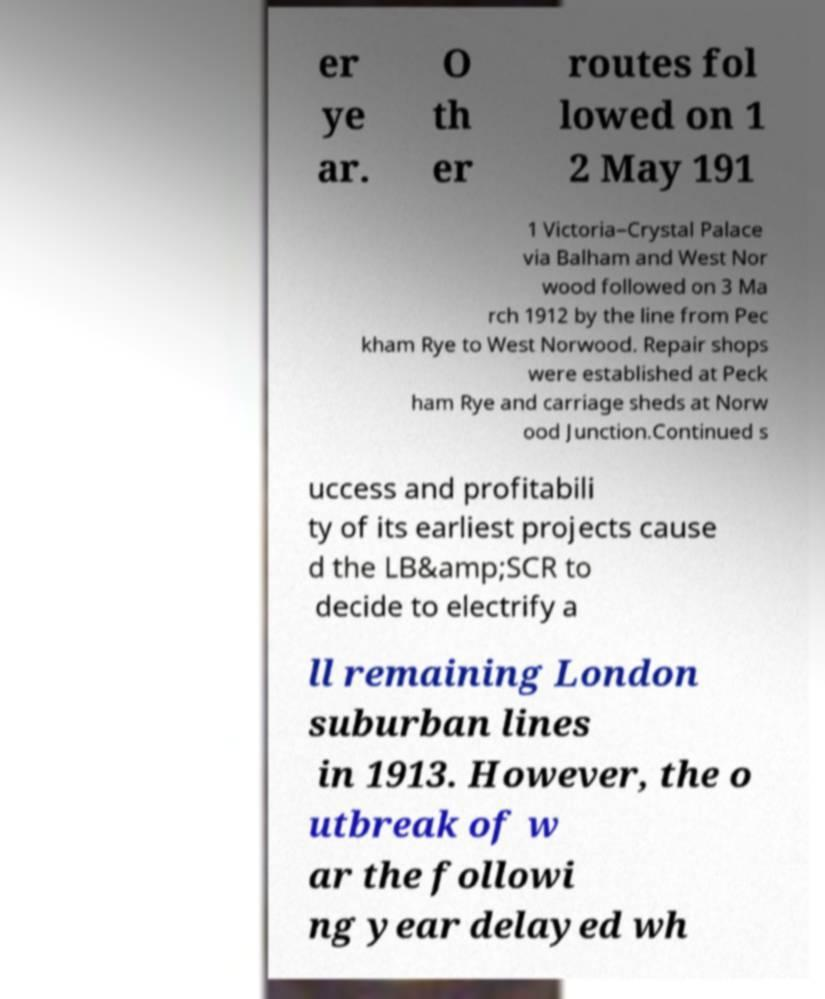Could you extract and type out the text from this image? er ye ar. O th er routes fol lowed on 1 2 May 191 1 Victoria–Crystal Palace via Balham and West Nor wood followed on 3 Ma rch 1912 by the line from Pec kham Rye to West Norwood. Repair shops were established at Peck ham Rye and carriage sheds at Norw ood Junction.Continued s uccess and profitabili ty of its earliest projects cause d the LB&amp;SCR to decide to electrify a ll remaining London suburban lines in 1913. However, the o utbreak of w ar the followi ng year delayed wh 